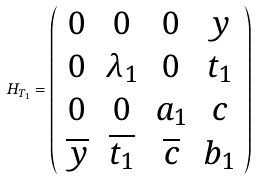<formula> <loc_0><loc_0><loc_500><loc_500>H _ { T _ { 1 } } = \left ( \begin{array} { c c c c } 0 & 0 & 0 & y \\ 0 & \lambda _ { 1 } & 0 & t _ { 1 } \\ 0 & 0 & a _ { 1 } & c \\ \overline { y } & \overline { t _ { 1 } } & \overline { c } & b _ { 1 } \end{array} \right )</formula> 